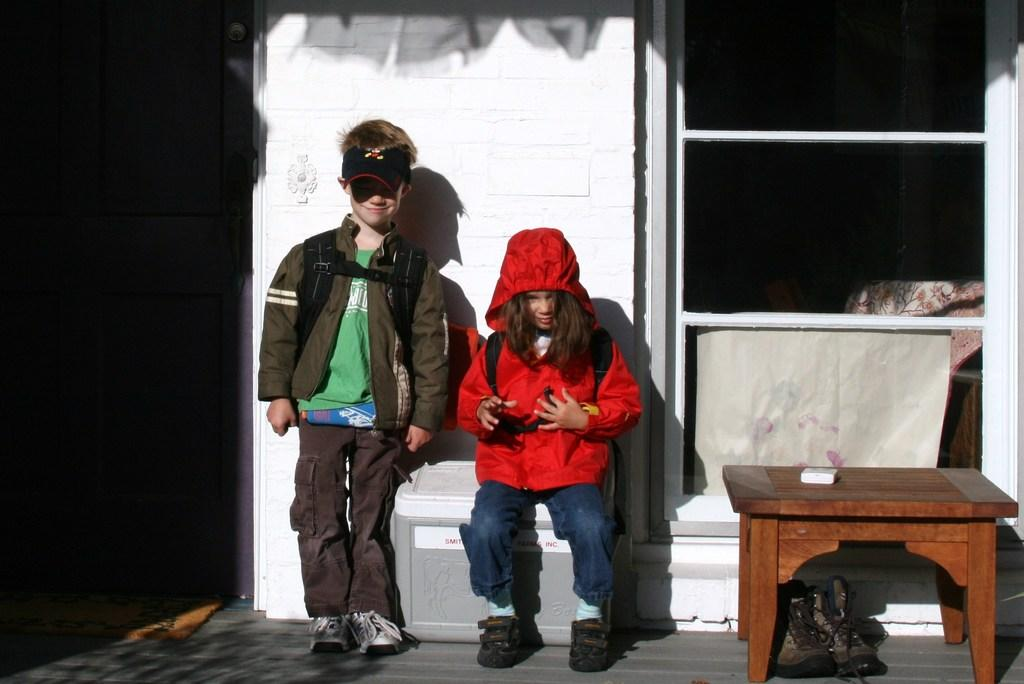What is the girl doing in the image? The girl is sitting in the image. What is the boy doing in the image? The boy is standing in the image. What piece of furniture is present in the image? There is a table in the image. What architectural feature can be seen in the image? There is a door in the image. What is the background of the image made of? There is a wall in the image. What allows natural light to enter the room in the image? There is a window in the image. What type of amusement park can be seen in the background of the image? There is no amusement park visible in the image; it only features a girl sitting, a boy standing, a table, a door, a wall, and a window. 